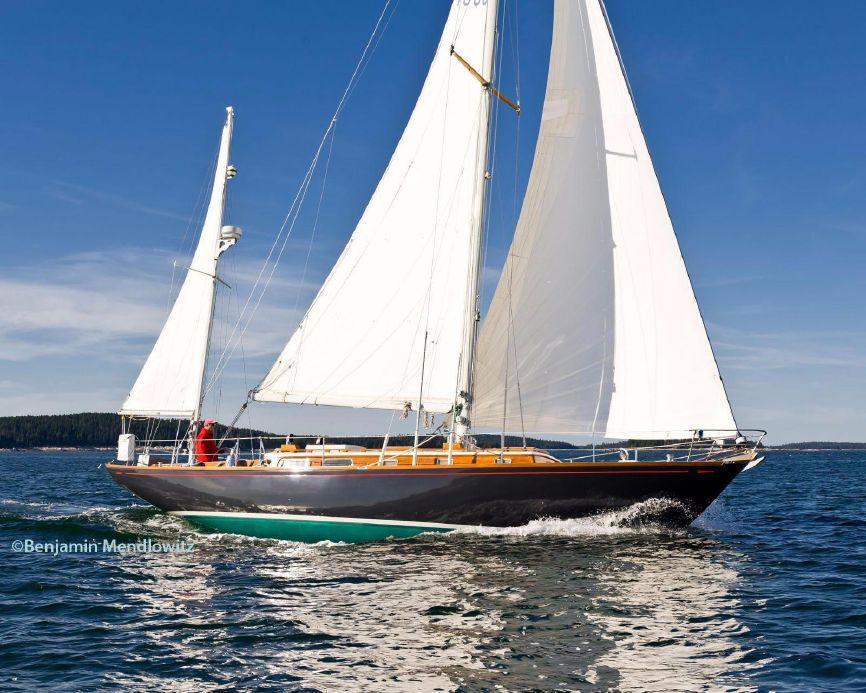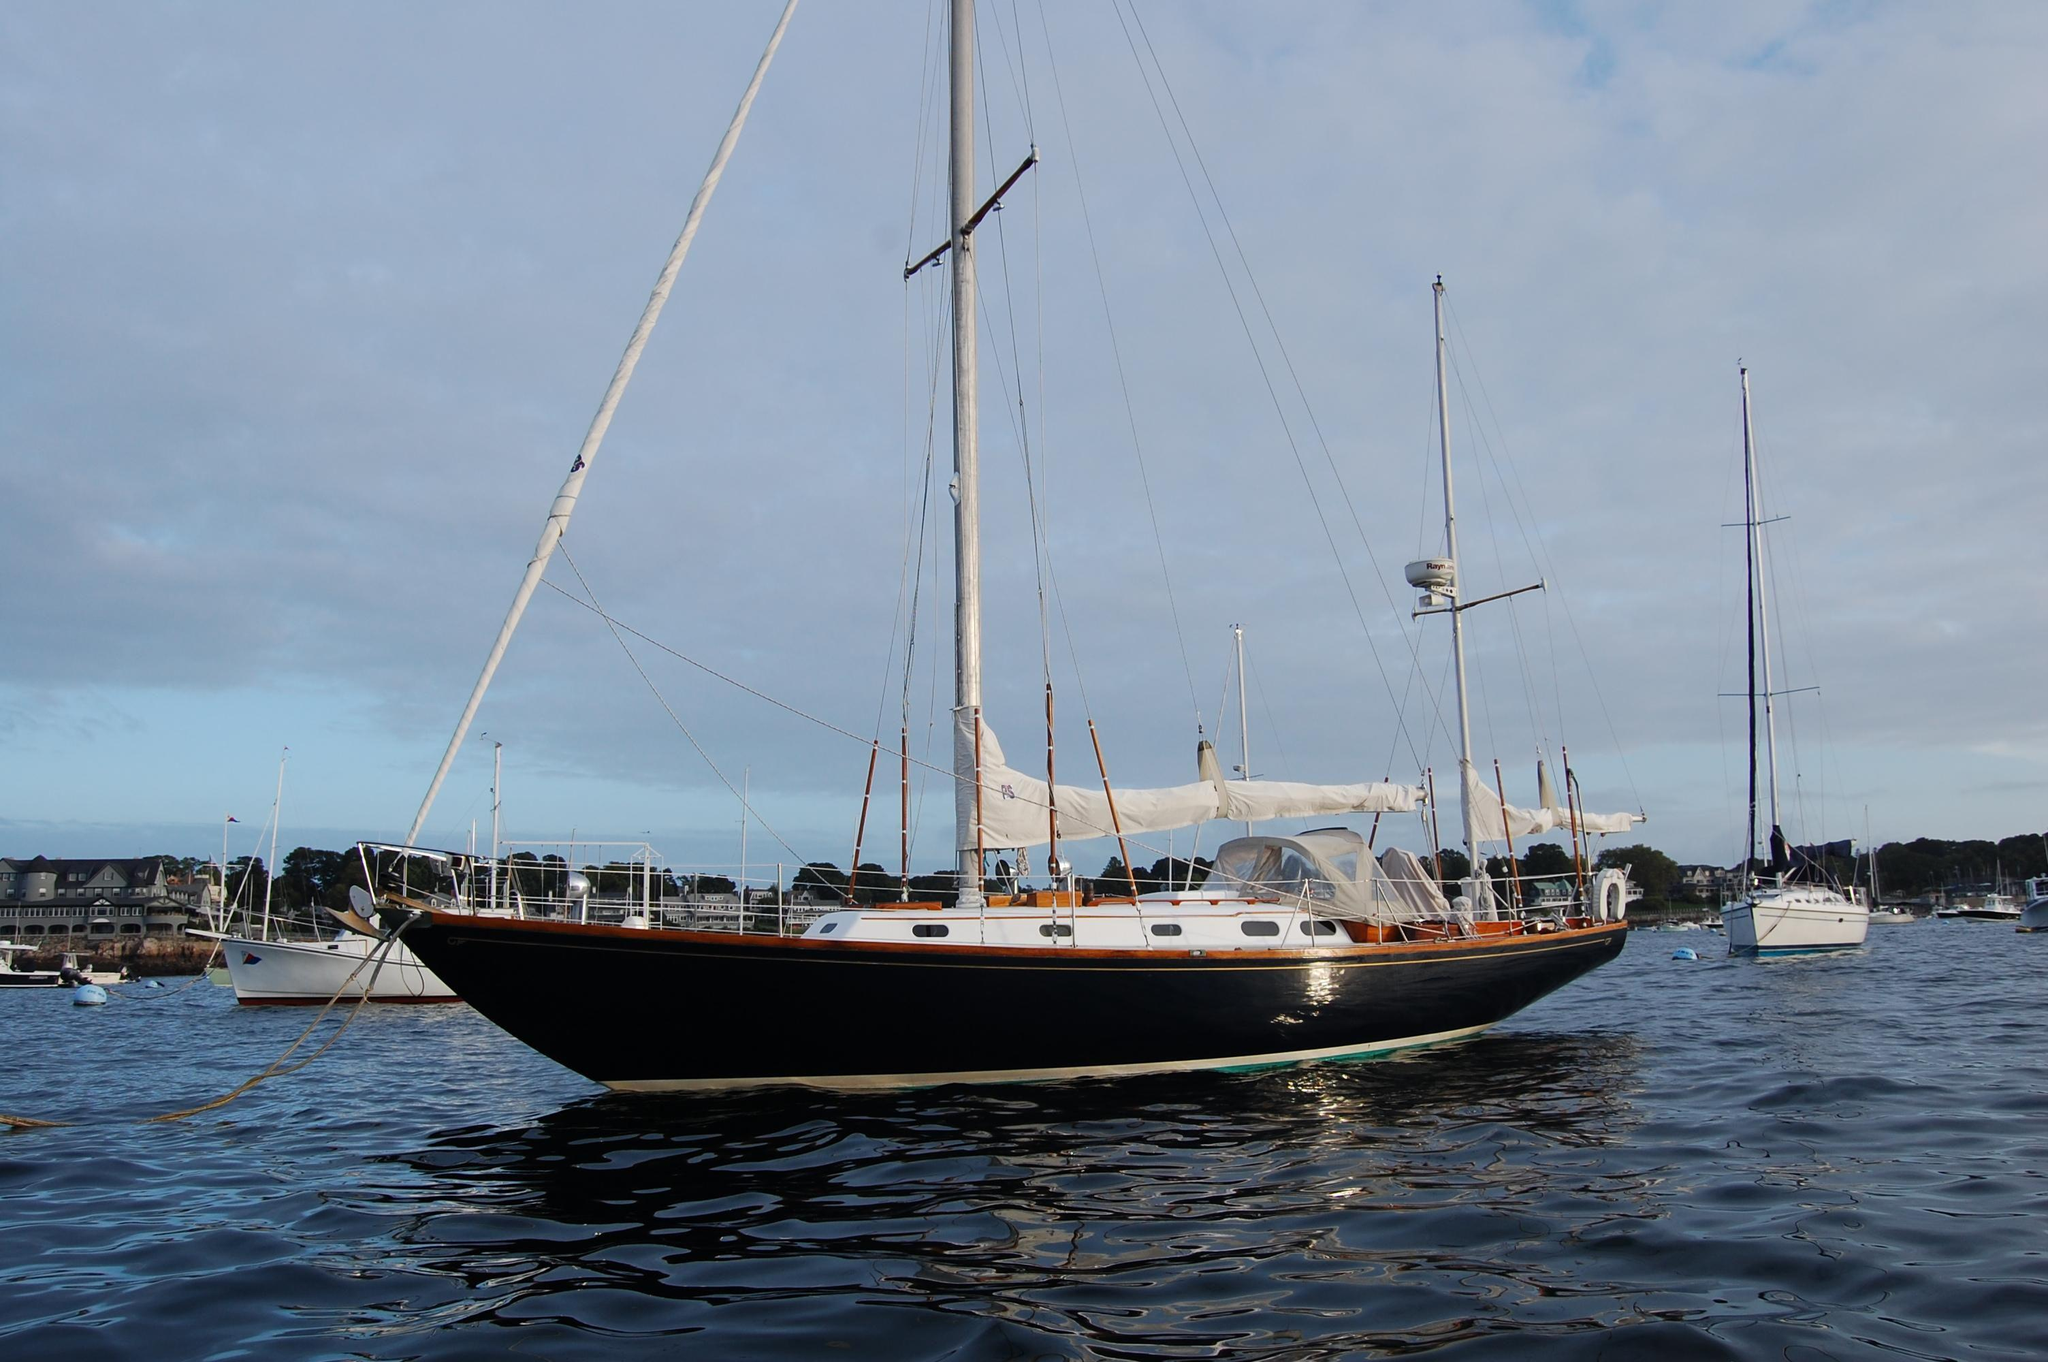The first image is the image on the left, the second image is the image on the right. Assess this claim about the two images: "On the right side of an image, a floating buoy extends from a boat into the water by a rope.". Correct or not? Answer yes or no. No. The first image is the image on the left, the second image is the image on the right. Examine the images to the left and right. Is the description "The sailboat in the image on the right has a black body." accurate? Answer yes or no. Yes. 